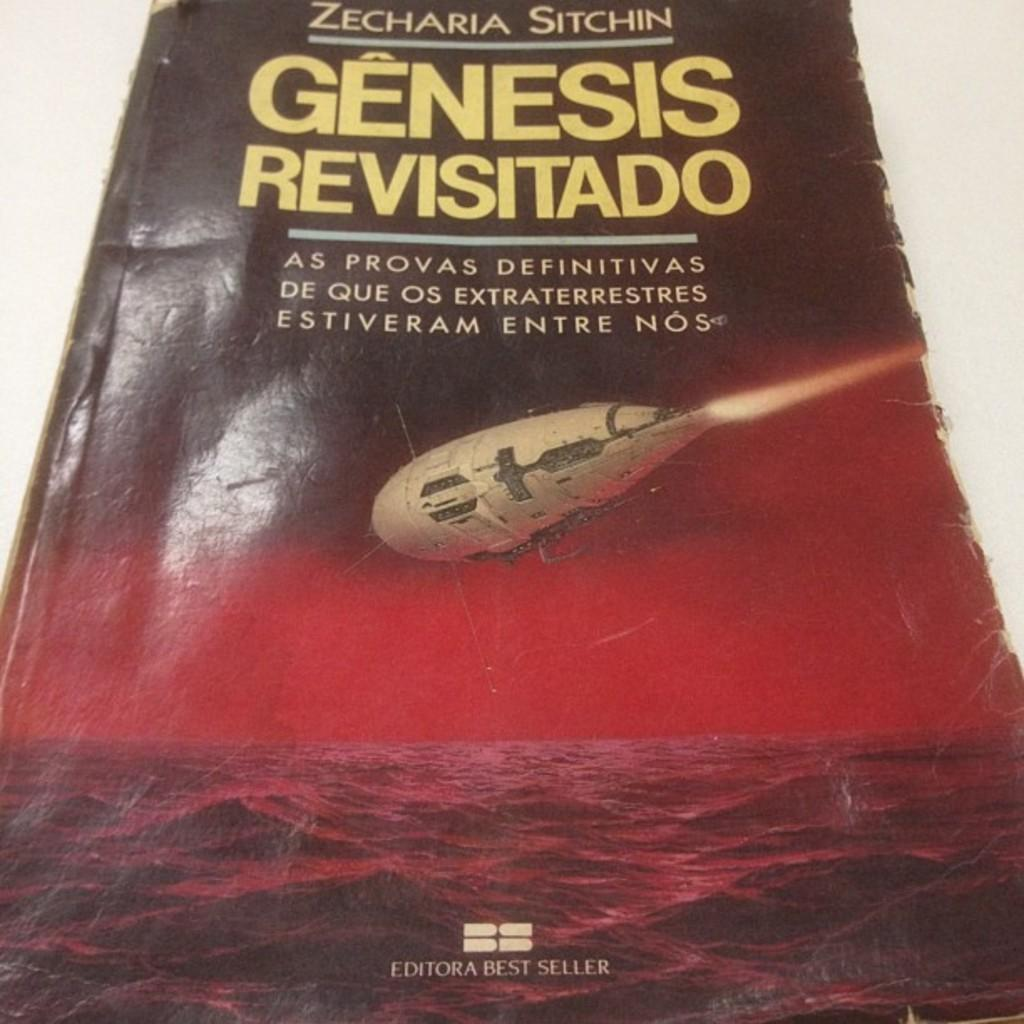Provide a one-sentence caption for the provided image. The book written by Zecharia Sitchin is titles Genensis Revisitado. 